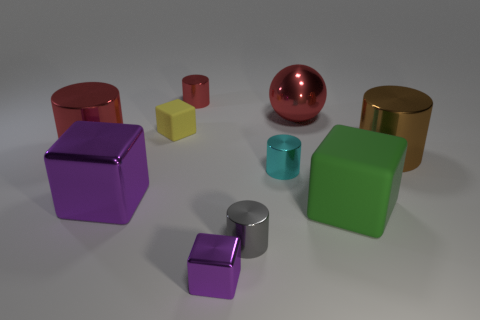There is another metal block that is the same color as the large metallic cube; what size is it? small 